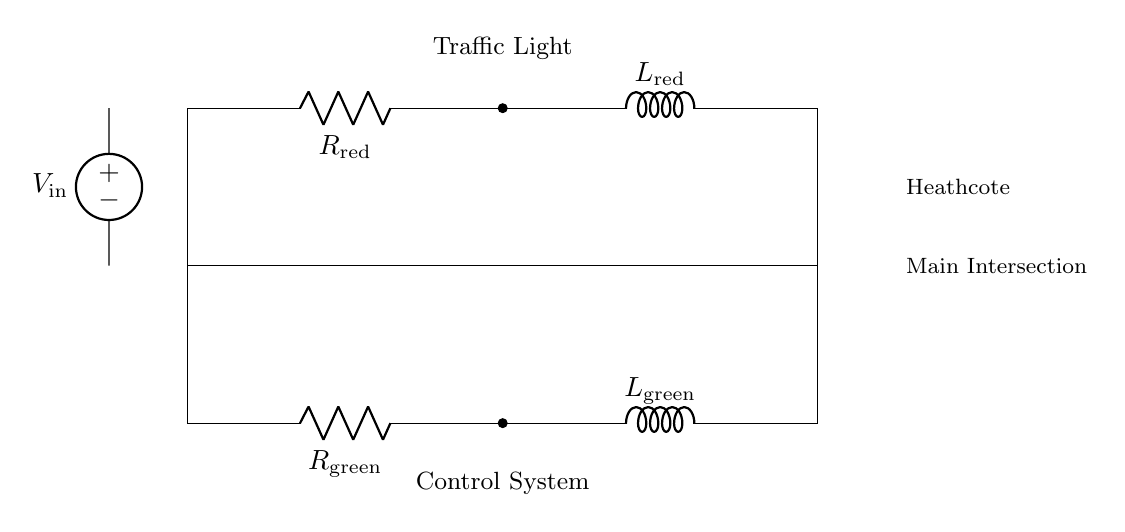What components are present in the circuit? The circuit includes two resistors and two inductors, labeled as R1, L1, R2, and L2.
Answer: Resistor and inductor What is the purpose of R1? R1 is the resistor connected to the red light indicator in the traffic light control system.
Answer: Red light resistor How many voltage sources are there in the circuit? There is one voltage source indicated in the diagram.
Answer: One What happens if the red light is activated? If the red light is activated, the current flows through R1 and L1, causing a delay as the inductor builds up its magnetic field.
Answer: Delay in transition What is the relationship between R1 and L1 in this circuit? R1 and L1 form an RL circuit, where R1 controls the current flow and L1 influences the time it takes for the current to reach its maximum value.
Answer: RL circuit What is the function of the inductor L2? L2 serves to delay the current flow to the green light circuit, allowing for a smoother transition from red to green.
Answer: Smoother transition Which part of the circuit is responsible for controlling the green light? The lower part of the circuit, which contains R2 and L2, is responsible for controlling the green light.
Answer: Lower part 